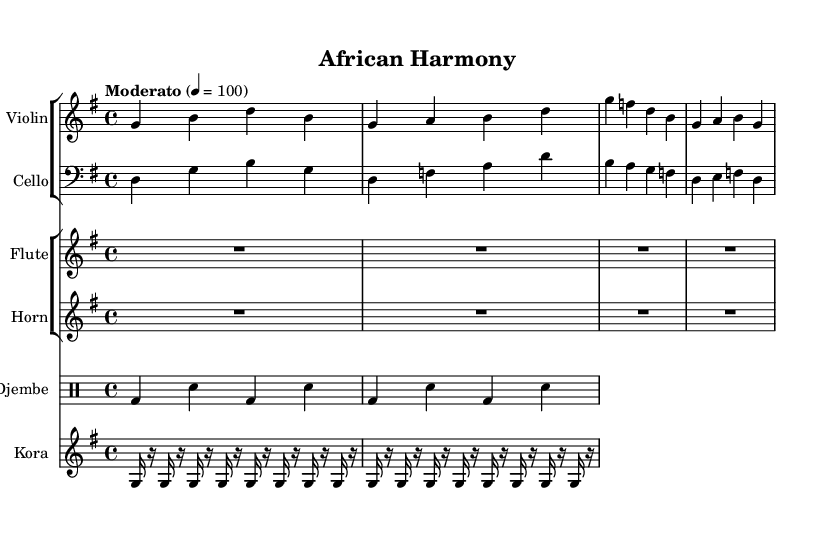What is the key signature of this music? The key signature is G major, which has one sharp (F#). You can find the key signature indicated at the beginning of the score.
Answer: G major What is the time signature of this music? The time signature is 4/4, noted at the beginning of the score, which indicates that there are four beats in each measure and the quarter note gets one beat.
Answer: 4/4 What is the tempo marking for this symphony? The tempo marking indicates "Moderato," which is a moderate speed. This can also be verified from the tempo notation placed before the score.
Answer: Moderato How many measures are in the violin part? The violin part consists of four measures. Each measure is divided by vertical lines, and counting the measures confirms that there are four of them.
Answer: Four What type of drum is used in this symphony? The drum used in this symphony is a djembe, as indicated in the instrument name in the drum staff.
Answer: Djembe What does "R1*4" signify in the flute and horn music? The "R1*4" indicates a rest for the duration of four beats in both the flute and horn parts. This is where the instruments are not playing.
Answer: Four beats rest What instrument plays the repeated pattern "g16 r g r g r..."? The instrument playing this pattern is the kora. The notation shows it clearly with its specific range and decorative notation unique to the kora.
Answer: Kora 